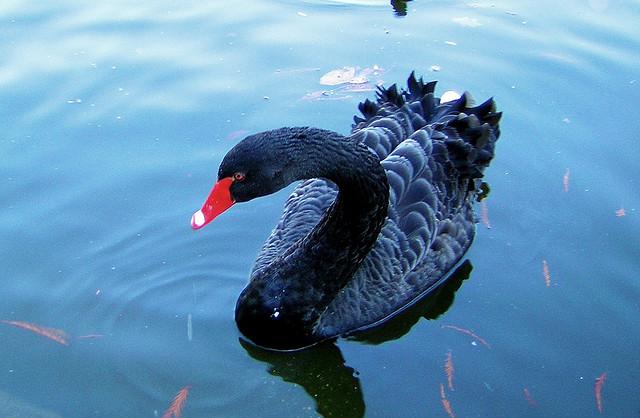What color is its beak?
Be succinct. Red. Where are the reflections?
Be succinct. In water. What kind of bird is this?
Concise answer only. Swan. 